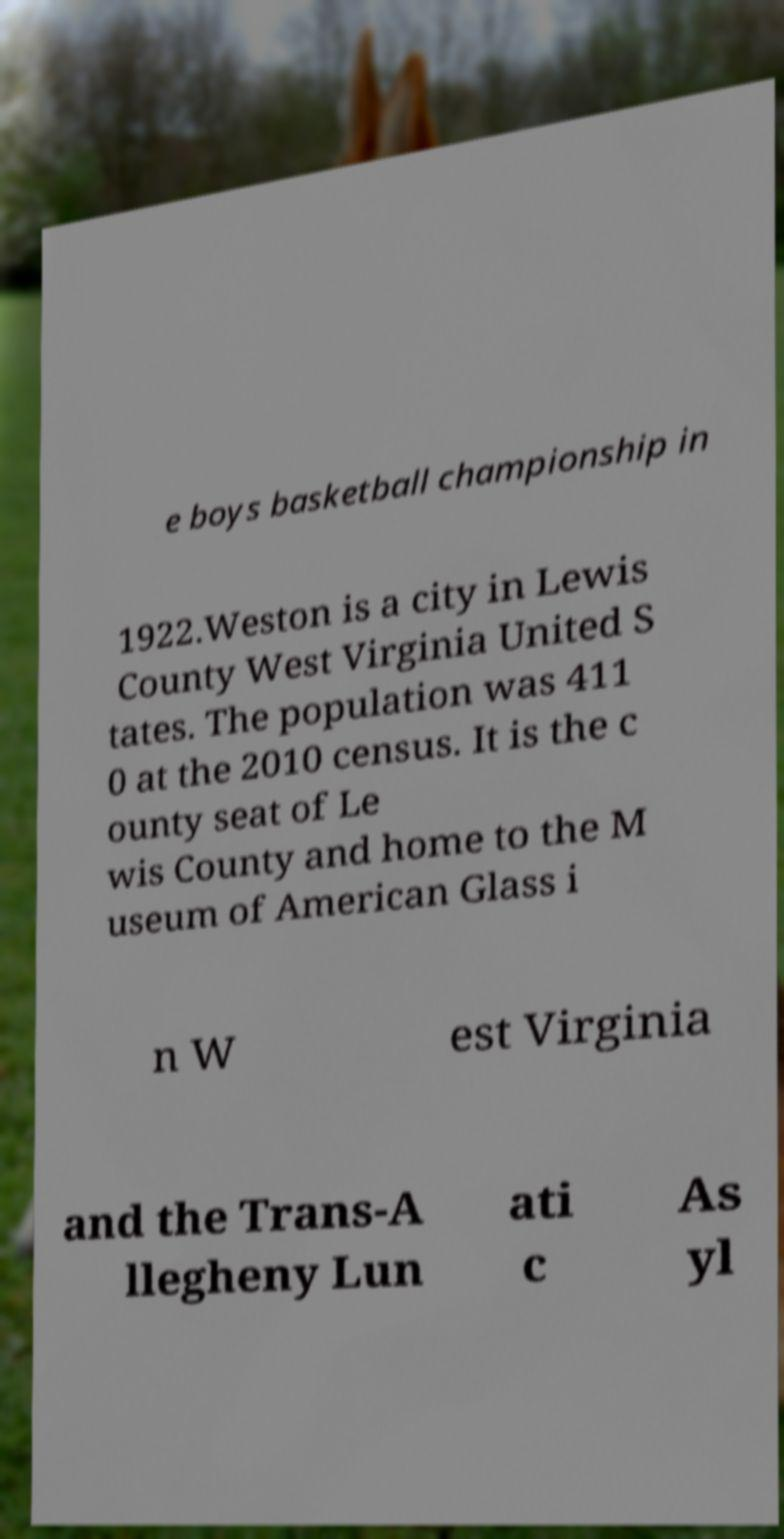For documentation purposes, I need the text within this image transcribed. Could you provide that? e boys basketball championship in 1922.Weston is a city in Lewis County West Virginia United S tates. The population was 411 0 at the 2010 census. It is the c ounty seat of Le wis County and home to the M useum of American Glass i n W est Virginia and the Trans-A llegheny Lun ati c As yl 